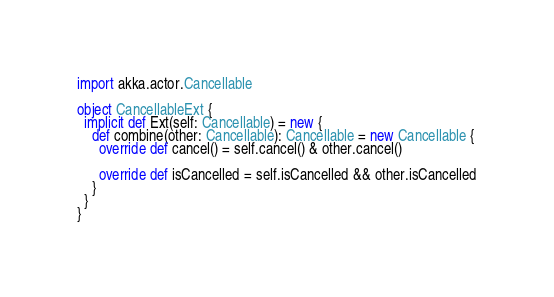Convert code to text. <code><loc_0><loc_0><loc_500><loc_500><_Scala_>import akka.actor.Cancellable

object CancellableExt {
  implicit def Ext(self: Cancellable) = new {
    def combine(other: Cancellable): Cancellable = new Cancellable {
      override def cancel() = self.cancel() & other.cancel()

      override def isCancelled = self.isCancelled && other.isCancelled
    }
  }
}</code> 